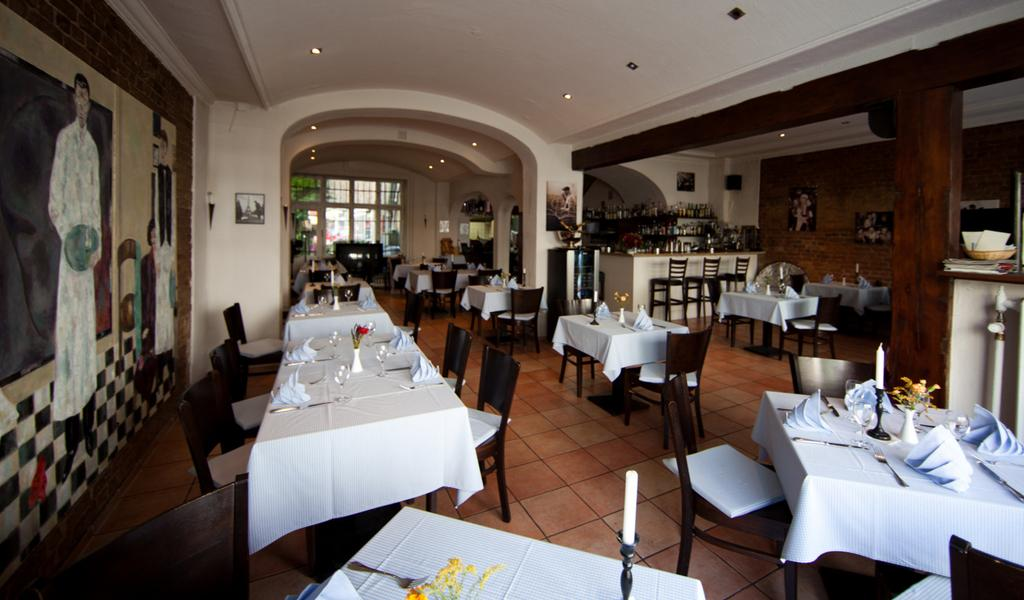What type of furniture can be seen in the image? There are tables and chairs in the image. What items related to decoration or personal belongings can be seen in the image? There are clothes, flower vases, candles, frames, bottles, and other objects in the image. What architectural elements are present in the image? There is a floor, a ceiling, and pillars in the image. What type of lighting is present in the image? There are lights in the image. Can you describe the motion of the basketball in the image? There is no basketball present in the image. Is there a kitty playing with the clothes in the image? There is no kitty present in the image. 